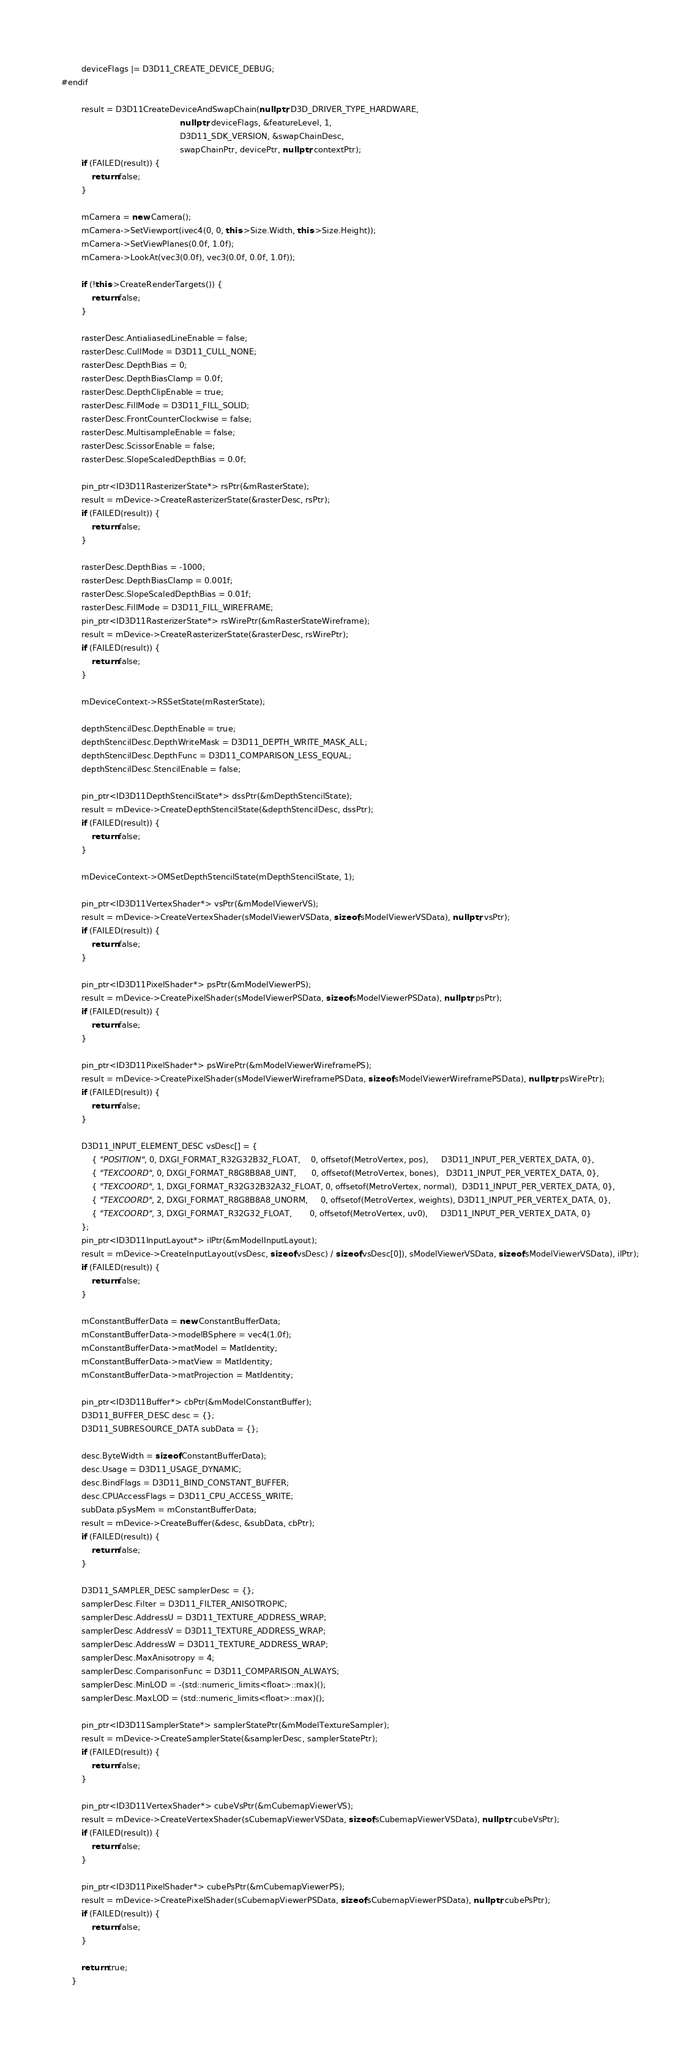<code> <loc_0><loc_0><loc_500><loc_500><_C++_>        deviceFlags |= D3D11_CREATE_DEVICE_DEBUG;
#endif

        result = D3D11CreateDeviceAndSwapChain(nullptr, D3D_DRIVER_TYPE_HARDWARE,
                                               nullptr, deviceFlags, &featureLevel, 1,
                                               D3D11_SDK_VERSION, &swapChainDesc,
                                               swapChainPtr, devicePtr, nullptr, contextPtr);
        if (FAILED(result)) {
            return false;
        }

        mCamera = new Camera();
        mCamera->SetViewport(ivec4(0, 0, this->Size.Width, this->Size.Height));
        mCamera->SetViewPlanes(0.0f, 1.0f);
        mCamera->LookAt(vec3(0.0f), vec3(0.0f, 0.0f, 1.0f));

        if (!this->CreateRenderTargets()) {
            return false;
        }

        rasterDesc.AntialiasedLineEnable = false;
        rasterDesc.CullMode = D3D11_CULL_NONE;
        rasterDesc.DepthBias = 0;
        rasterDesc.DepthBiasClamp = 0.0f;
        rasterDesc.DepthClipEnable = true;
        rasterDesc.FillMode = D3D11_FILL_SOLID;
        rasterDesc.FrontCounterClockwise = false;
        rasterDesc.MultisampleEnable = false;
        rasterDesc.ScissorEnable = false;
        rasterDesc.SlopeScaledDepthBias = 0.0f;

        pin_ptr<ID3D11RasterizerState*> rsPtr(&mRasterState);
        result = mDevice->CreateRasterizerState(&rasterDesc, rsPtr);
        if (FAILED(result)) {
            return false;
        }

        rasterDesc.DepthBias = -1000;
        rasterDesc.DepthBiasClamp = 0.001f;
        rasterDesc.SlopeScaledDepthBias = 0.01f;
        rasterDesc.FillMode = D3D11_FILL_WIREFRAME;
        pin_ptr<ID3D11RasterizerState*> rsWirePtr(&mRasterStateWireframe);
        result = mDevice->CreateRasterizerState(&rasterDesc, rsWirePtr);
        if (FAILED(result)) {
            return false;
        }

        mDeviceContext->RSSetState(mRasterState);

        depthStencilDesc.DepthEnable = true;
        depthStencilDesc.DepthWriteMask = D3D11_DEPTH_WRITE_MASK_ALL;
        depthStencilDesc.DepthFunc = D3D11_COMPARISON_LESS_EQUAL;
        depthStencilDesc.StencilEnable = false;

        pin_ptr<ID3D11DepthStencilState*> dssPtr(&mDepthStencilState);
        result = mDevice->CreateDepthStencilState(&depthStencilDesc, dssPtr);
        if (FAILED(result)) {
            return false;
        }

        mDeviceContext->OMSetDepthStencilState(mDepthStencilState, 1);

        pin_ptr<ID3D11VertexShader*> vsPtr(&mModelViewerVS);
        result = mDevice->CreateVertexShader(sModelViewerVSData, sizeof(sModelViewerVSData), nullptr, vsPtr);
        if (FAILED(result)) {
            return false;
        }

        pin_ptr<ID3D11PixelShader*> psPtr(&mModelViewerPS);
        result = mDevice->CreatePixelShader(sModelViewerPSData, sizeof(sModelViewerPSData), nullptr, psPtr);
        if (FAILED(result)) {
            return false;
        }

        pin_ptr<ID3D11PixelShader*> psWirePtr(&mModelViewerWireframePS);
        result = mDevice->CreatePixelShader(sModelViewerWireframePSData, sizeof(sModelViewerWireframePSData), nullptr, psWirePtr);
        if (FAILED(result)) {
            return false;
        }

        D3D11_INPUT_ELEMENT_DESC vsDesc[] = {
            { "POSITION", 0, DXGI_FORMAT_R32G32B32_FLOAT,    0, offsetof(MetroVertex, pos),     D3D11_INPUT_PER_VERTEX_DATA, 0},
            { "TEXCOORD", 0, DXGI_FORMAT_R8G8B8A8_UINT,      0, offsetof(MetroVertex, bones),   D3D11_INPUT_PER_VERTEX_DATA, 0},
            { "TEXCOORD", 1, DXGI_FORMAT_R32G32B32A32_FLOAT, 0, offsetof(MetroVertex, normal),  D3D11_INPUT_PER_VERTEX_DATA, 0},
            { "TEXCOORD", 2, DXGI_FORMAT_R8G8B8A8_UNORM,     0, offsetof(MetroVertex, weights), D3D11_INPUT_PER_VERTEX_DATA, 0},
            { "TEXCOORD", 3, DXGI_FORMAT_R32G32_FLOAT,       0, offsetof(MetroVertex, uv0),     D3D11_INPUT_PER_VERTEX_DATA, 0}
        };
        pin_ptr<ID3D11InputLayout*> ilPtr(&mModelInputLayout);
        result = mDevice->CreateInputLayout(vsDesc, sizeof(vsDesc) / sizeof(vsDesc[0]), sModelViewerVSData, sizeof(sModelViewerVSData), ilPtr);
        if (FAILED(result)) {
            return false;
        }

        mConstantBufferData = new ConstantBufferData;
        mConstantBufferData->modelBSphere = vec4(1.0f);
        mConstantBufferData->matModel = MatIdentity;
        mConstantBufferData->matView = MatIdentity;
        mConstantBufferData->matProjection = MatIdentity;

        pin_ptr<ID3D11Buffer*> cbPtr(&mModelConstantBuffer);
        D3D11_BUFFER_DESC desc = {};
        D3D11_SUBRESOURCE_DATA subData = {};

        desc.ByteWidth = sizeof(ConstantBufferData);
        desc.Usage = D3D11_USAGE_DYNAMIC;
        desc.BindFlags = D3D11_BIND_CONSTANT_BUFFER;
        desc.CPUAccessFlags = D3D11_CPU_ACCESS_WRITE;
        subData.pSysMem = mConstantBufferData;
        result = mDevice->CreateBuffer(&desc, &subData, cbPtr);
        if (FAILED(result)) {
            return false;
        }

        D3D11_SAMPLER_DESC samplerDesc = {};
        samplerDesc.Filter = D3D11_FILTER_ANISOTROPIC;
        samplerDesc.AddressU = D3D11_TEXTURE_ADDRESS_WRAP;
        samplerDesc.AddressV = D3D11_TEXTURE_ADDRESS_WRAP;
        samplerDesc.AddressW = D3D11_TEXTURE_ADDRESS_WRAP;
        samplerDesc.MaxAnisotropy = 4;
        samplerDesc.ComparisonFunc = D3D11_COMPARISON_ALWAYS;
        samplerDesc.MinLOD = -(std::numeric_limits<float>::max)();
        samplerDesc.MaxLOD = (std::numeric_limits<float>::max)();

        pin_ptr<ID3D11SamplerState*> samplerStatePtr(&mModelTextureSampler);
        result = mDevice->CreateSamplerState(&samplerDesc, samplerStatePtr);
        if (FAILED(result)) {
            return false;
        }

        pin_ptr<ID3D11VertexShader*> cubeVsPtr(&mCubemapViewerVS);
        result = mDevice->CreateVertexShader(sCubemapViewerVSData, sizeof(sCubemapViewerVSData), nullptr, cubeVsPtr);
        if (FAILED(result)) {
            return false;
        }

        pin_ptr<ID3D11PixelShader*> cubePsPtr(&mCubemapViewerPS);
        result = mDevice->CreatePixelShader(sCubemapViewerPSData, sizeof(sCubemapViewerPSData), nullptr, cubePsPtr);
        if (FAILED(result)) {
            return false;
        }

        return true;
    }
</code> 